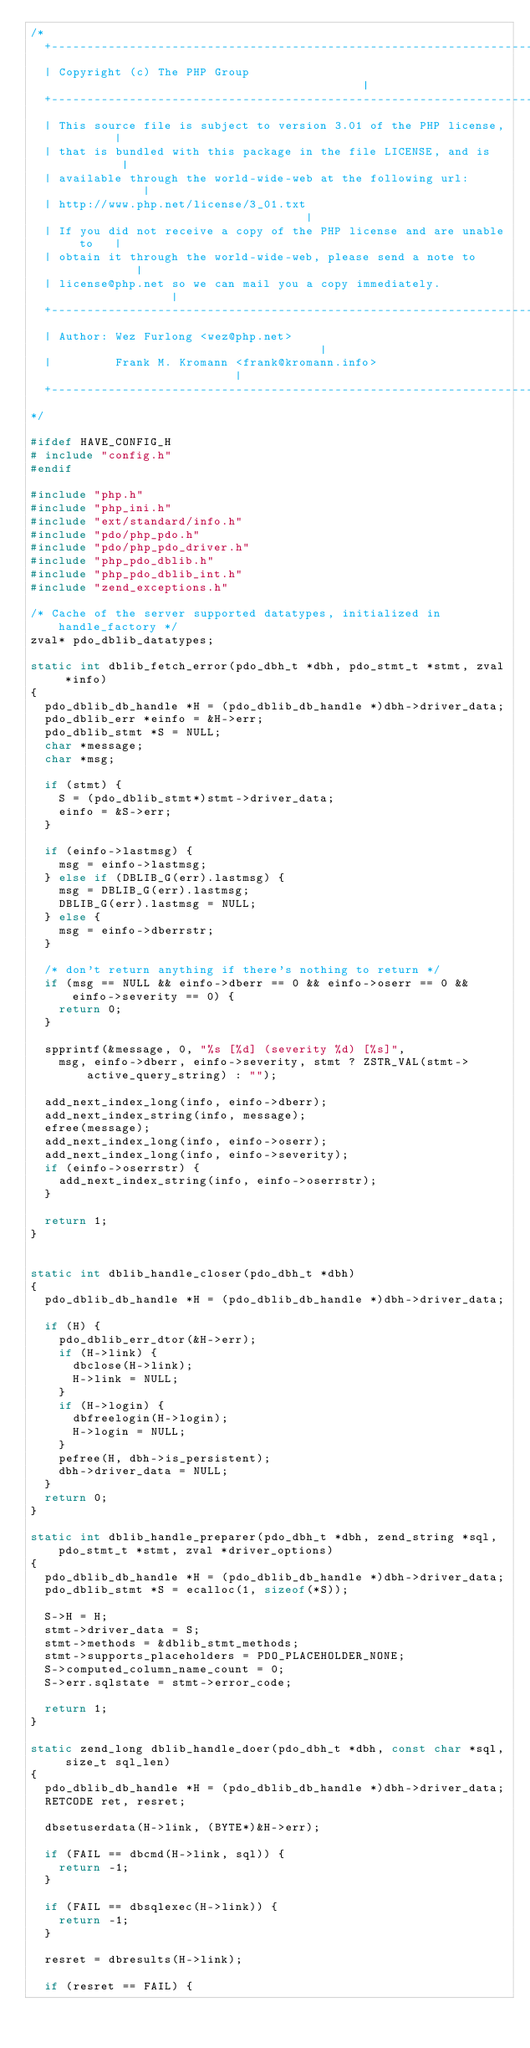<code> <loc_0><loc_0><loc_500><loc_500><_C_>/*
  +----------------------------------------------------------------------+
  | Copyright (c) The PHP Group                                          |
  +----------------------------------------------------------------------+
  | This source file is subject to version 3.01 of the PHP license,      |
  | that is bundled with this package in the file LICENSE, and is        |
  | available through the world-wide-web at the following url:           |
  | http://www.php.net/license/3_01.txt                                  |
  | If you did not receive a copy of the PHP license and are unable to   |
  | obtain it through the world-wide-web, please send a note to          |
  | license@php.net so we can mail you a copy immediately.               |
  +----------------------------------------------------------------------+
  | Author: Wez Furlong <wez@php.net>                                    |
  |         Frank M. Kromann <frank@kromann.info>                        |
  +----------------------------------------------------------------------+
*/

#ifdef HAVE_CONFIG_H
# include "config.h"
#endif

#include "php.h"
#include "php_ini.h"
#include "ext/standard/info.h"
#include "pdo/php_pdo.h"
#include "pdo/php_pdo_driver.h"
#include "php_pdo_dblib.h"
#include "php_pdo_dblib_int.h"
#include "zend_exceptions.h"

/* Cache of the server supported datatypes, initialized in handle_factory */
zval* pdo_dblib_datatypes;

static int dblib_fetch_error(pdo_dbh_t *dbh, pdo_stmt_t *stmt, zval *info)
{
	pdo_dblib_db_handle *H = (pdo_dblib_db_handle *)dbh->driver_data;
	pdo_dblib_err *einfo = &H->err;
	pdo_dblib_stmt *S = NULL;
	char *message;
	char *msg;

	if (stmt) {
		S = (pdo_dblib_stmt*)stmt->driver_data;
		einfo = &S->err;
	}

	if (einfo->lastmsg) {
		msg = einfo->lastmsg;
	} else if (DBLIB_G(err).lastmsg) {
		msg = DBLIB_G(err).lastmsg;
		DBLIB_G(err).lastmsg = NULL;
	} else {
		msg = einfo->dberrstr;
	}

	/* don't return anything if there's nothing to return */
	if (msg == NULL && einfo->dberr == 0 && einfo->oserr == 0 && einfo->severity == 0) {
		return 0;
	}

	spprintf(&message, 0, "%s [%d] (severity %d) [%s]",
		msg, einfo->dberr, einfo->severity, stmt ? ZSTR_VAL(stmt->active_query_string) : "");

	add_next_index_long(info, einfo->dberr);
	add_next_index_string(info, message);
	efree(message);
	add_next_index_long(info, einfo->oserr);
	add_next_index_long(info, einfo->severity);
	if (einfo->oserrstr) {
		add_next_index_string(info, einfo->oserrstr);
	}

	return 1;
}


static int dblib_handle_closer(pdo_dbh_t *dbh)
{
	pdo_dblib_db_handle *H = (pdo_dblib_db_handle *)dbh->driver_data;

	if (H) {
		pdo_dblib_err_dtor(&H->err);
		if (H->link) {
			dbclose(H->link);
			H->link = NULL;
		}
		if (H->login) {
			dbfreelogin(H->login);
			H->login = NULL;
		}
		pefree(H, dbh->is_persistent);
		dbh->driver_data = NULL;
	}
	return 0;
}

static int dblib_handle_preparer(pdo_dbh_t *dbh, zend_string *sql, pdo_stmt_t *stmt, zval *driver_options)
{
	pdo_dblib_db_handle *H = (pdo_dblib_db_handle *)dbh->driver_data;
	pdo_dblib_stmt *S = ecalloc(1, sizeof(*S));

	S->H = H;
	stmt->driver_data = S;
	stmt->methods = &dblib_stmt_methods;
	stmt->supports_placeholders = PDO_PLACEHOLDER_NONE;
	S->computed_column_name_count = 0;
	S->err.sqlstate = stmt->error_code;

	return 1;
}

static zend_long dblib_handle_doer(pdo_dbh_t *dbh, const char *sql, size_t sql_len)
{
	pdo_dblib_db_handle *H = (pdo_dblib_db_handle *)dbh->driver_data;
	RETCODE ret, resret;

	dbsetuserdata(H->link, (BYTE*)&H->err);

	if (FAIL == dbcmd(H->link, sql)) {
		return -1;
	}

	if (FAIL == dbsqlexec(H->link)) {
		return -1;
	}

	resret = dbresults(H->link);

	if (resret == FAIL) {</code> 